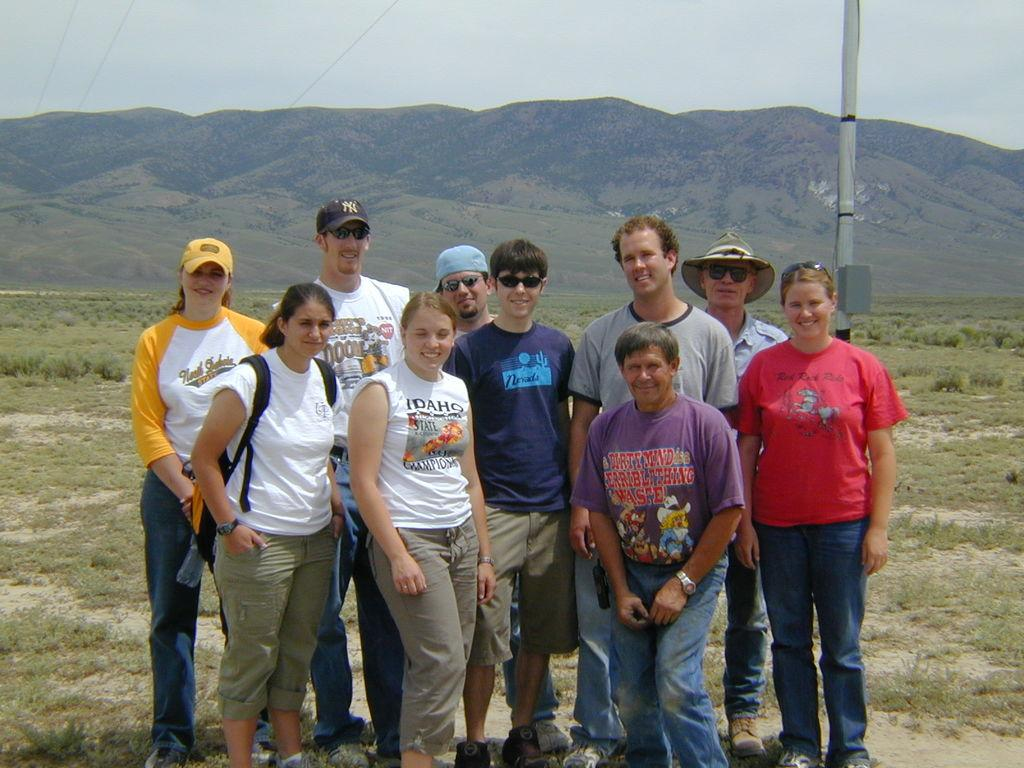How many people are in the image? There is a group of people in the image. What is the facial expression of the people in the image? The people are smiling. Where are the people standing in the image? The people are standing on the ground. What type of vegetation is visible in the image? There is grass visible in the image. What is the tall, vertical object in the image? There is a pole in the image. What can be seen in the distance in the image? There are mountains in the background of the image. What is visible above the mountains in the image? The sky is visible in the background of the image. What type of cars are parked near the mountains in the image? There are no cars present in the image; it features a group of people standing on grass with a pole and mountains in the background. 